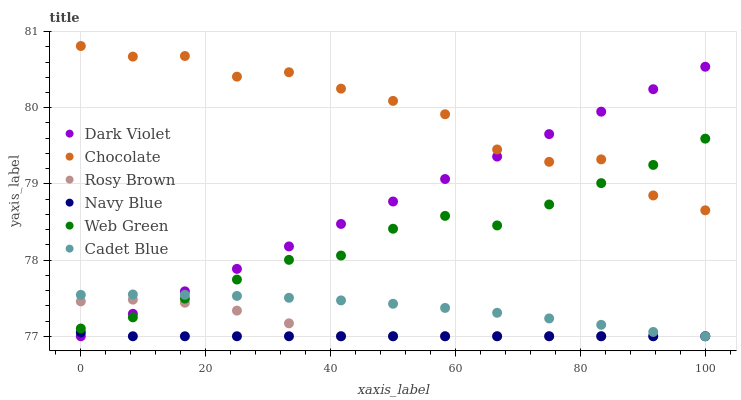Does Navy Blue have the minimum area under the curve?
Answer yes or no. Yes. Does Chocolate have the maximum area under the curve?
Answer yes or no. Yes. Does Rosy Brown have the minimum area under the curve?
Answer yes or no. No. Does Rosy Brown have the maximum area under the curve?
Answer yes or no. No. Is Dark Violet the smoothest?
Answer yes or no. Yes. Is Chocolate the roughest?
Answer yes or no. Yes. Is Navy Blue the smoothest?
Answer yes or no. No. Is Navy Blue the roughest?
Answer yes or no. No. Does Cadet Blue have the lowest value?
Answer yes or no. Yes. Does Web Green have the lowest value?
Answer yes or no. No. Does Chocolate have the highest value?
Answer yes or no. Yes. Does Rosy Brown have the highest value?
Answer yes or no. No. Is Navy Blue less than Chocolate?
Answer yes or no. Yes. Is Chocolate greater than Cadet Blue?
Answer yes or no. Yes. Does Rosy Brown intersect Cadet Blue?
Answer yes or no. Yes. Is Rosy Brown less than Cadet Blue?
Answer yes or no. No. Is Rosy Brown greater than Cadet Blue?
Answer yes or no. No. Does Navy Blue intersect Chocolate?
Answer yes or no. No. 